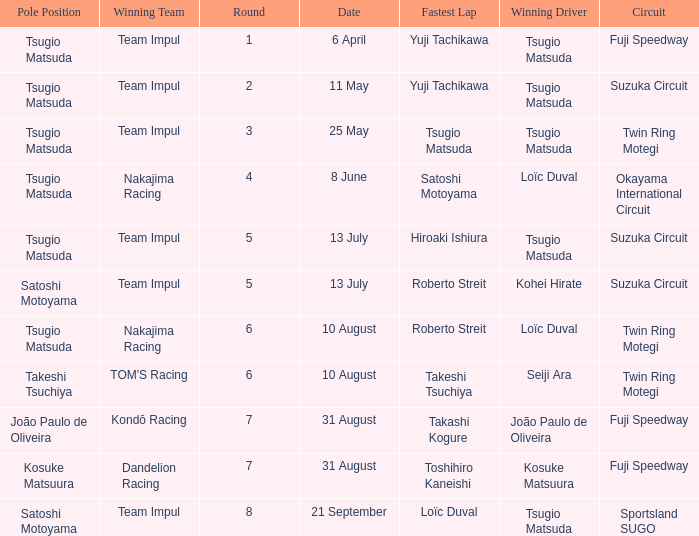Help me parse the entirety of this table. {'header': ['Pole Position', 'Winning Team', 'Round', 'Date', 'Fastest Lap', 'Winning Driver', 'Circuit'], 'rows': [['Tsugio Matsuda', 'Team Impul', '1', '6 April', 'Yuji Tachikawa', 'Tsugio Matsuda', 'Fuji Speedway'], ['Tsugio Matsuda', 'Team Impul', '2', '11 May', 'Yuji Tachikawa', 'Tsugio Matsuda', 'Suzuka Circuit'], ['Tsugio Matsuda', 'Team Impul', '3', '25 May', 'Tsugio Matsuda', 'Tsugio Matsuda', 'Twin Ring Motegi'], ['Tsugio Matsuda', 'Nakajima Racing', '4', '8 June', 'Satoshi Motoyama', 'Loïc Duval', 'Okayama International Circuit'], ['Tsugio Matsuda', 'Team Impul', '5', '13 July', 'Hiroaki Ishiura', 'Tsugio Matsuda', 'Suzuka Circuit'], ['Satoshi Motoyama', 'Team Impul', '5', '13 July', 'Roberto Streit', 'Kohei Hirate', 'Suzuka Circuit'], ['Tsugio Matsuda', 'Nakajima Racing', '6', '10 August', 'Roberto Streit', 'Loïc Duval', 'Twin Ring Motegi'], ['Takeshi Tsuchiya', "TOM'S Racing", '6', '10 August', 'Takeshi Tsuchiya', 'Seiji Ara', 'Twin Ring Motegi'], ['João Paulo de Oliveira', 'Kondō Racing', '7', '31 August', 'Takashi Kogure', 'João Paulo de Oliveira', 'Fuji Speedway'], ['Kosuke Matsuura', 'Dandelion Racing', '7', '31 August', 'Toshihiro Kaneishi', 'Kosuke Matsuura', 'Fuji Speedway'], ['Satoshi Motoyama', 'Team Impul', '8', '21 September', 'Loïc Duval', 'Tsugio Matsuda', 'Sportsland SUGO']]} In round 1, on which date did yuji tachikawa record the fastest lap time? 6 April. 